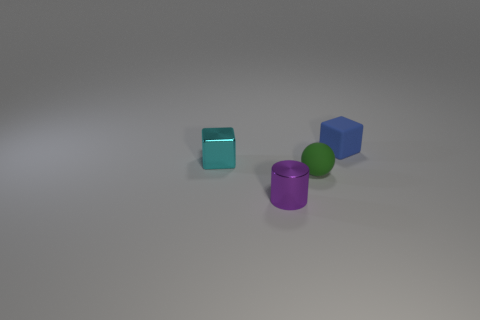Add 1 small cyan things. How many objects exist? 5 Subtract all balls. How many objects are left? 3 Add 4 tiny objects. How many tiny objects exist? 8 Subtract 0 brown cubes. How many objects are left? 4 Subtract all green matte balls. Subtract all large red cubes. How many objects are left? 3 Add 2 small cyan shiny objects. How many small cyan shiny objects are left? 3 